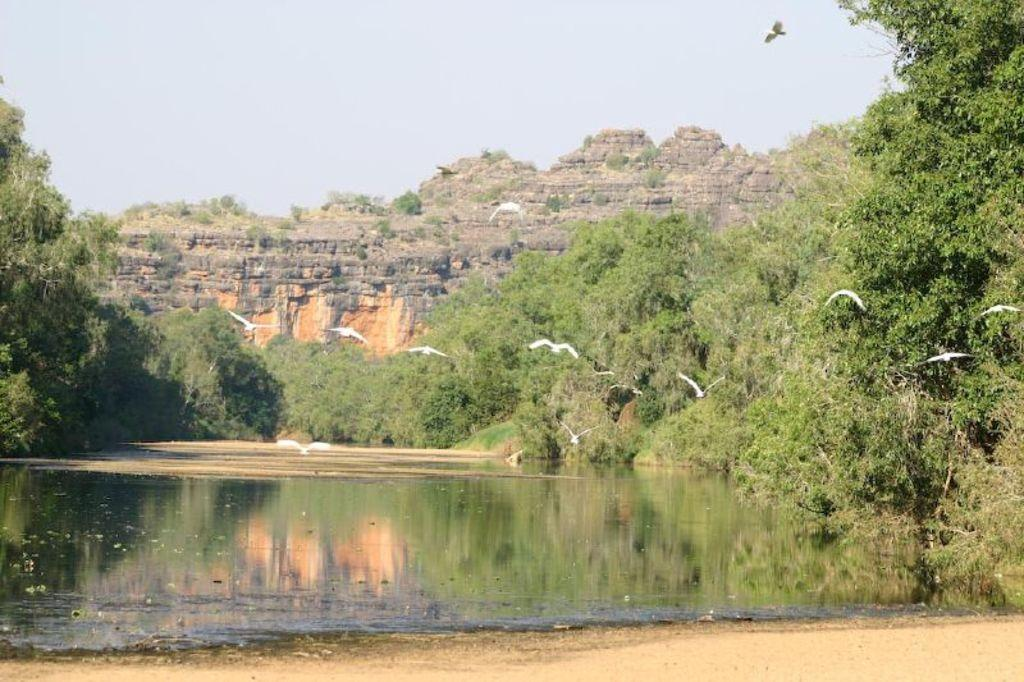What type of water body is present in the image? There is a small water lake in the image. What can be seen flying in the sky in the image? There are white color birds flying in the sky. What type of vegetation is visible in the image? There are trees visible in the image. What type of geographical feature is present in the background of the image? There is a rock mountain in the background of the image. How many kittens are attempting to climb the rock mountain in the image? There are no kittens present in the image, and therefore no such attempt can be observed. What type of mist can be seen surrounding the trees in the image? There is no mist present in the image; the trees are visible without any mist. 